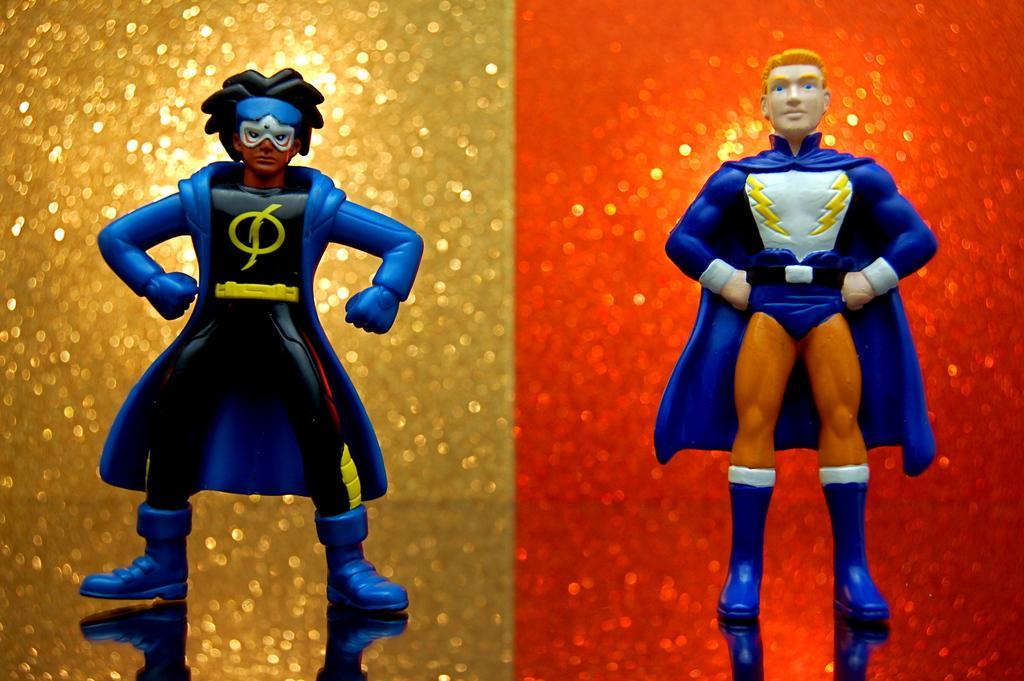Describe this image in one or two sentences. In this image I can see two toys. In the background there are two colors. One is gold in color and the other one is red in color. 